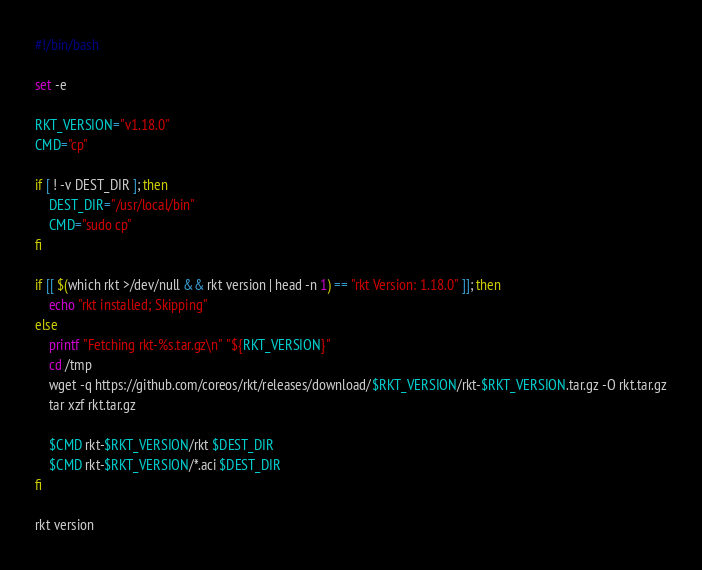Convert code to text. <code><loc_0><loc_0><loc_500><loc_500><_Bash_>#!/bin/bash

set -e

RKT_VERSION="v1.18.0"
CMD="cp"

if [ ! -v DEST_DIR ]; then
	DEST_DIR="/usr/local/bin"
	CMD="sudo cp"
fi

if [[ $(which rkt >/dev/null && rkt version | head -n 1) == "rkt Version: 1.18.0" ]]; then
    echo "rkt installed; Skipping"
else
    printf "Fetching rkt-%s.tar.gz\n" "${RKT_VERSION}"
    cd /tmp
    wget -q https://github.com/coreos/rkt/releases/download/$RKT_VERSION/rkt-$RKT_VERSION.tar.gz -O rkt.tar.gz
    tar xzf rkt.tar.gz

    $CMD rkt-$RKT_VERSION/rkt $DEST_DIR
    $CMD rkt-$RKT_VERSION/*.aci $DEST_DIR
fi

rkt version
</code> 